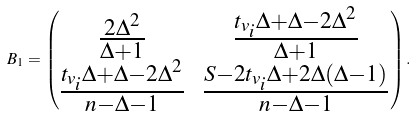Convert formula to latex. <formula><loc_0><loc_0><loc_500><loc_500>B _ { 1 } = \begin{pmatrix} \frac { 2 \Delta ^ { 2 } } { \Delta + 1 } & \frac { t _ { v _ { i } } \Delta + \Delta - 2 \Delta ^ { 2 } } { \Delta + 1 } \\ \frac { t _ { v _ { i } } \Delta + \Delta - 2 \Delta ^ { 2 } } { n - \Delta - 1 } & \frac { S - 2 t _ { v _ { i } } \Delta + 2 \Delta ( \Delta - 1 ) } { n - \Delta - 1 } \end{pmatrix} .</formula> 